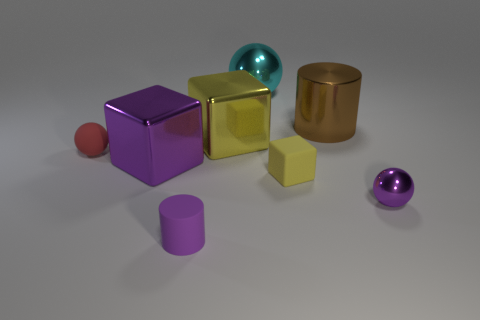Which objects appear to be closest to the viewer? The objects closest to the viewer are the small red sphere and the yellow cube. Both are positioned towards the front of the image and appear slightly larger due to their proximity.  Is there any object that stands out in the image because of its size or position? The large purple cube stands out due to its size and central position. Its distinctive reflective surface and vibrant color also draw the eye, making it a focal point in the composition. 